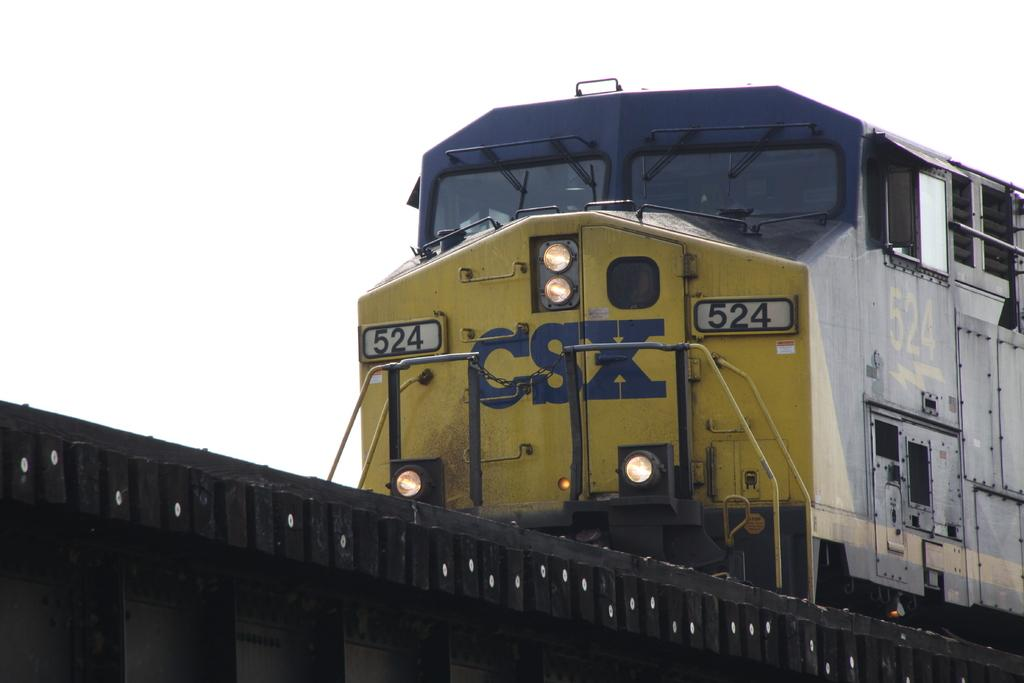What is the main subject of the image? The main subject of the image is a train. What colors can be seen on the train? The train has blue and yellow colors. What is the train moving on? The train is moving on an iron platform. What numbers and letters are written on the train? The train has numbers "524" and letters "CSX" written on it. How many lights are on the train, and what is their current state? There are 4 lights on the train, and they are ON. Can you see the body of the person who believes in the power of the tongue in the image? There is no person or reference to a tongue in the image; it features a train with specific details. 